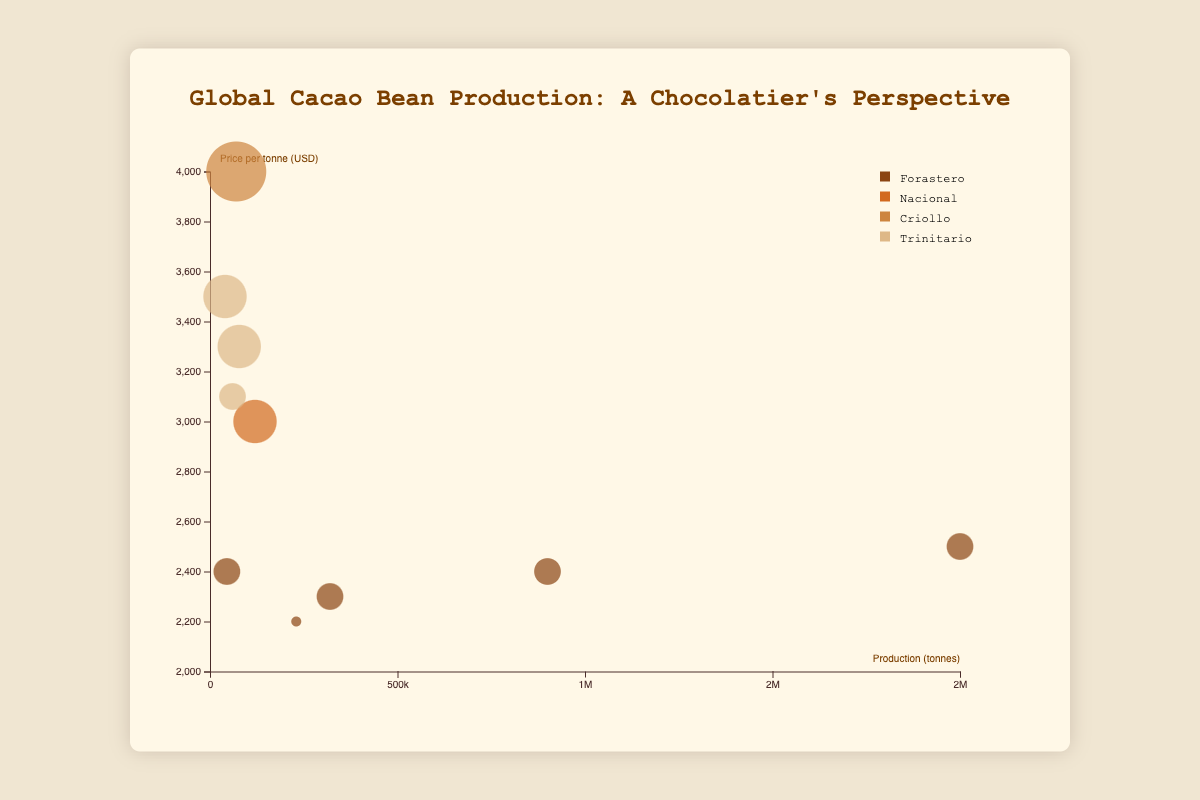What is the title of the chart? The title of the chart is located at the top of the visualization and provides a summary of the content of the figure.
Answer: Global Cacao Bean Production: A Chocolatier's Perspective Which country has the highest cacao bean production? Looking at the x-axis, which represents production in tonnes, the country with the point farthest to the right has the highest production.
Answer: Ivory Coast Which cacao variety is associated with the highest price per tonne? By examining the y-axis, which represents price per tonne in USD, the highest point indicates the cacao variety with the highest price.
Answer: Criollo How many countries produce Forastero cacao beans? Identify the bubbles with the color associated with Forastero, and count how many different countries they represent.
Answer: 6 What is the average production of cacao beans produced by Ivory Coast and Ghana combined? Sum the production of Ivory Coast (2000000) and Ghana (900000) and then divide by 2. (2000000 + 900000) / 2 = 1450000
Answer: 1450000 tonnes Which country has the highest quality rating for its cacao beans? The size of the bubbles represents the quality rating. Identify the largest bubble to determine the country with the highest rating.
Answer: Peru Which country has the lowest price per tonne for its cacao beans? Find the point that is closest to the bottom of the y-axis, which represents the lowest price per tonne.
Answer: Nigeria Compare the production between Ecuador and Peru. Which country produces more cacao beans? Look at the x-axis values for both countries. Ecuador has a higher x-axis value compared to Peru.
Answer: Ecuador What is the relationship between quality rating and price per tonne? Most bubbles with higher quality ratings (larger size) are also located higher on the y-axis, indicating higher prices per tonne.
Answer: Higher quality generally correlates with higher prices In terms of quality rating, how does Forastero cacao from Malaysia compare to Forastero cacao from Nigeria? Compare the size of the two bubbles representing Malaysia and Nigeria, which both have Forastero cacao. Malaysia's bubble size is larger.
Answer: Malaysia has a higher quality rating 